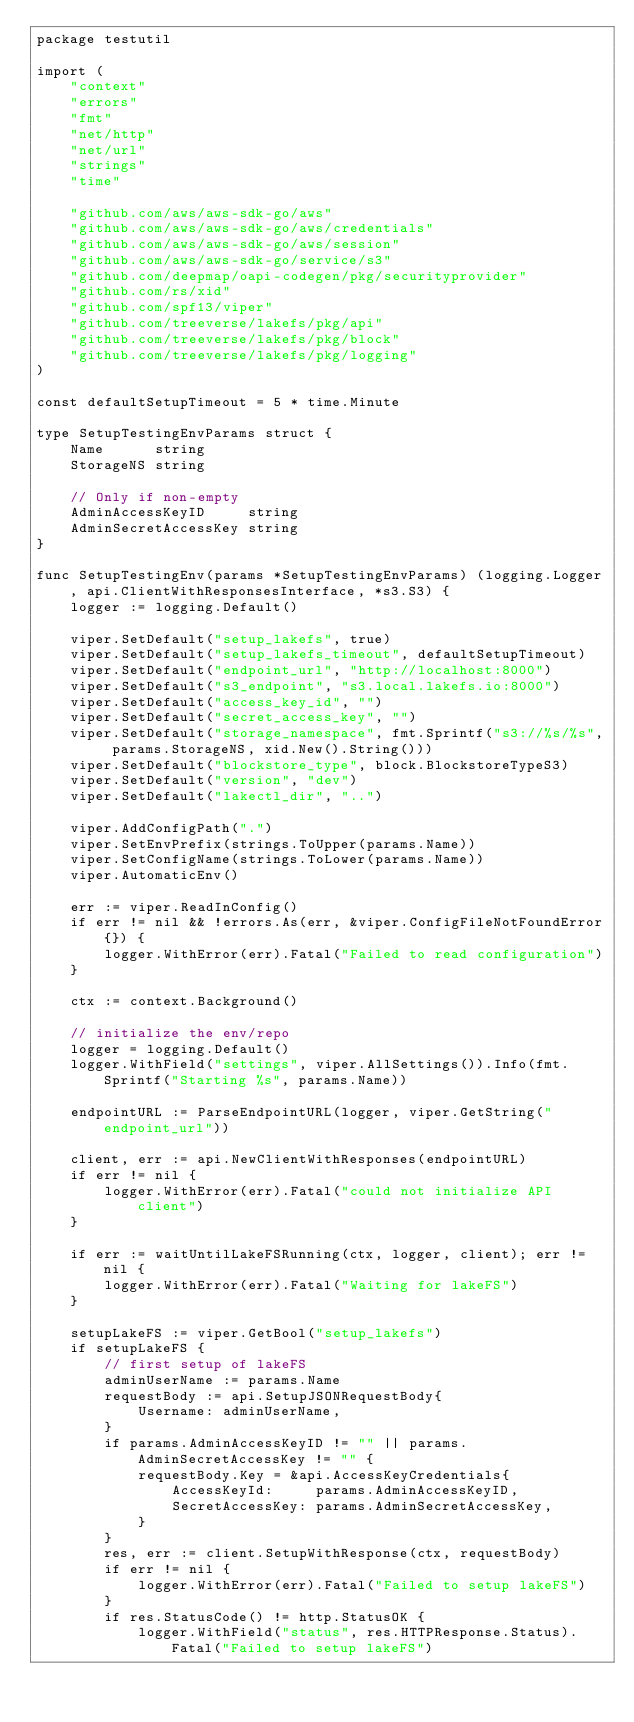Convert code to text. <code><loc_0><loc_0><loc_500><loc_500><_Go_>package testutil

import (
	"context"
	"errors"
	"fmt"
	"net/http"
	"net/url"
	"strings"
	"time"

	"github.com/aws/aws-sdk-go/aws"
	"github.com/aws/aws-sdk-go/aws/credentials"
	"github.com/aws/aws-sdk-go/aws/session"
	"github.com/aws/aws-sdk-go/service/s3"
	"github.com/deepmap/oapi-codegen/pkg/securityprovider"
	"github.com/rs/xid"
	"github.com/spf13/viper"
	"github.com/treeverse/lakefs/pkg/api"
	"github.com/treeverse/lakefs/pkg/block"
	"github.com/treeverse/lakefs/pkg/logging"
)

const defaultSetupTimeout = 5 * time.Minute

type SetupTestingEnvParams struct {
	Name      string
	StorageNS string

	// Only if non-empty
	AdminAccessKeyID     string
	AdminSecretAccessKey string
}

func SetupTestingEnv(params *SetupTestingEnvParams) (logging.Logger, api.ClientWithResponsesInterface, *s3.S3) {
	logger := logging.Default()

	viper.SetDefault("setup_lakefs", true)
	viper.SetDefault("setup_lakefs_timeout", defaultSetupTimeout)
	viper.SetDefault("endpoint_url", "http://localhost:8000")
	viper.SetDefault("s3_endpoint", "s3.local.lakefs.io:8000")
	viper.SetDefault("access_key_id", "")
	viper.SetDefault("secret_access_key", "")
	viper.SetDefault("storage_namespace", fmt.Sprintf("s3://%s/%s", params.StorageNS, xid.New().String()))
	viper.SetDefault("blockstore_type", block.BlockstoreTypeS3)
	viper.SetDefault("version", "dev")
	viper.SetDefault("lakectl_dir", "..")

	viper.AddConfigPath(".")
	viper.SetEnvPrefix(strings.ToUpper(params.Name))
	viper.SetConfigName(strings.ToLower(params.Name))
	viper.AutomaticEnv()

	err := viper.ReadInConfig()
	if err != nil && !errors.As(err, &viper.ConfigFileNotFoundError{}) {
		logger.WithError(err).Fatal("Failed to read configuration")
	}

	ctx := context.Background()

	// initialize the env/repo
	logger = logging.Default()
	logger.WithField("settings", viper.AllSettings()).Info(fmt.Sprintf("Starting %s", params.Name))

	endpointURL := ParseEndpointURL(logger, viper.GetString("endpoint_url"))

	client, err := api.NewClientWithResponses(endpointURL)
	if err != nil {
		logger.WithError(err).Fatal("could not initialize API client")
	}

	if err := waitUntilLakeFSRunning(ctx, logger, client); err != nil {
		logger.WithError(err).Fatal("Waiting for lakeFS")
	}

	setupLakeFS := viper.GetBool("setup_lakefs")
	if setupLakeFS {
		// first setup of lakeFS
		adminUserName := params.Name
		requestBody := api.SetupJSONRequestBody{
			Username: adminUserName,
		}
		if params.AdminAccessKeyID != "" || params.AdminSecretAccessKey != "" {
			requestBody.Key = &api.AccessKeyCredentials{
				AccessKeyId:     params.AdminAccessKeyID,
				SecretAccessKey: params.AdminSecretAccessKey,
			}
		}
		res, err := client.SetupWithResponse(ctx, requestBody)
		if err != nil {
			logger.WithError(err).Fatal("Failed to setup lakeFS")
		}
		if res.StatusCode() != http.StatusOK {
			logger.WithField("status", res.HTTPResponse.Status).Fatal("Failed to setup lakeFS")</code> 